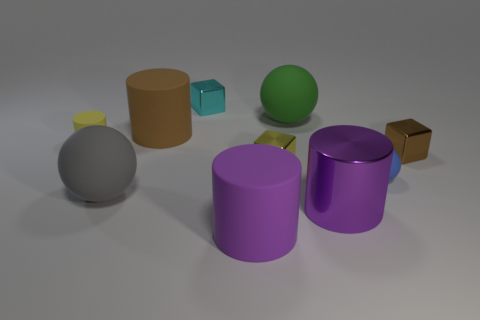Subtract all large spheres. How many spheres are left? 1 Subtract all yellow cylinders. How many cylinders are left? 3 Subtract all gray cylinders. Subtract all green cubes. How many cylinders are left? 4 Subtract all blocks. How many objects are left? 7 Add 10 small green shiny spheres. How many small green shiny spheres exist? 10 Subtract 1 brown cylinders. How many objects are left? 9 Subtract all small brown rubber objects. Subtract all large gray balls. How many objects are left? 9 Add 6 tiny cylinders. How many tiny cylinders are left? 7 